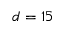Convert formula to latex. <formula><loc_0><loc_0><loc_500><loc_500>d = 1 5</formula> 